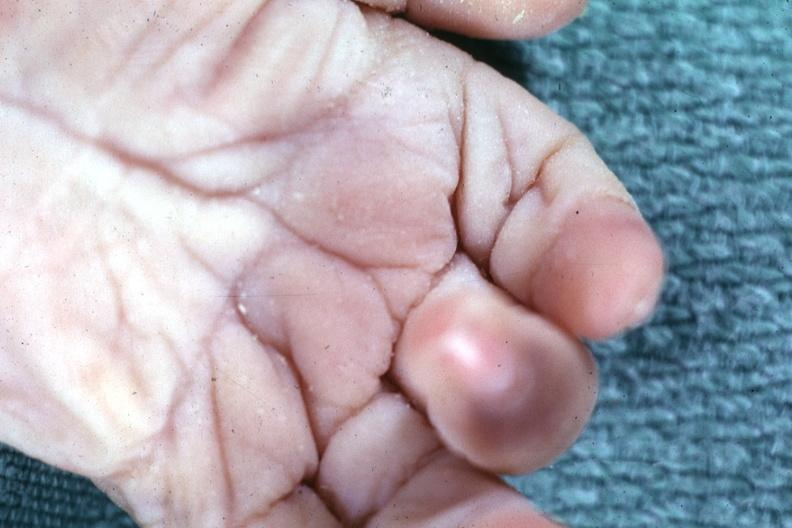does this image show simian crease?
Answer the question using a single word or phrase. Yes 